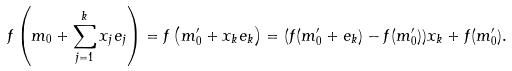Convert formula to latex. <formula><loc_0><loc_0><loc_500><loc_500>f \left ( m _ { 0 } + \sum _ { j = 1 } ^ { k } x _ { j } e _ { j } \right ) = f \left ( m ^ { \prime } _ { 0 } + x _ { k } e _ { k } \right ) = ( f ( m ^ { \prime } _ { 0 } + e _ { k } ) - f ( m ^ { \prime } _ { 0 } ) ) x _ { k } + f ( m ^ { \prime } _ { 0 } ) .</formula> 